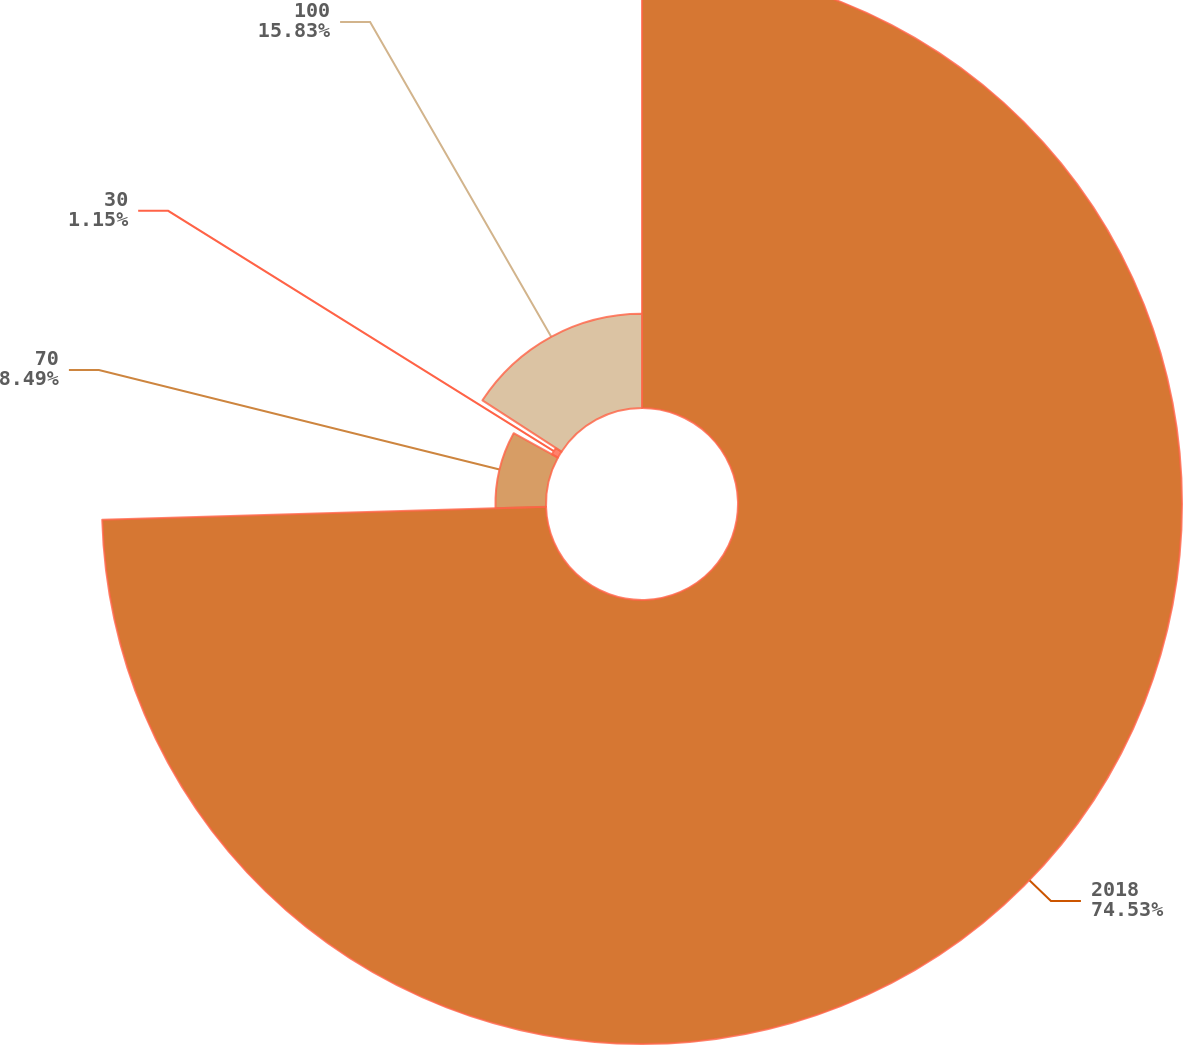Convert chart to OTSL. <chart><loc_0><loc_0><loc_500><loc_500><pie_chart><fcel>2018<fcel>70<fcel>30<fcel>100<nl><fcel>74.54%<fcel>8.49%<fcel>1.15%<fcel>15.83%<nl></chart> 